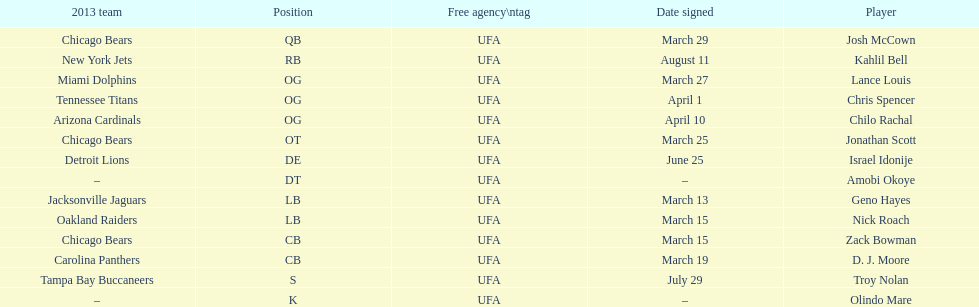How many free agents did this team pick up this season? 14. 